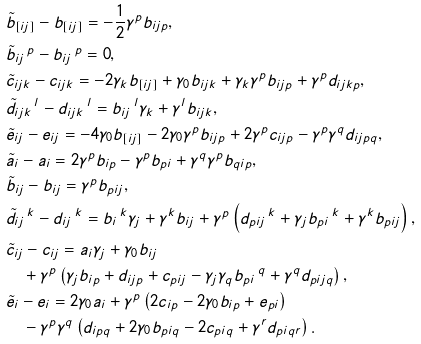Convert formula to latex. <formula><loc_0><loc_0><loc_500><loc_500>& \tilde { b } _ { [ i j ] } - b _ { [ i j ] } = - \frac { 1 } { 2 } \gamma ^ { p } b _ { i j p } , \\ & \tilde { b } _ { i j } \, ^ { p } - b _ { i j } \, ^ { p } = 0 , \\ & \tilde { c } _ { i j k } - c _ { i j k } = - 2 \gamma _ { k } b _ { [ i j ] } + \gamma _ { 0 } b _ { i j k } + \gamma _ { k } \gamma ^ { p } b _ { i j p } + \gamma ^ { p } d _ { i j k p } , \\ & \tilde { d } _ { i j k } \, ^ { l } - d _ { i j k } \, ^ { l } = b _ { i j } \, ^ { l } \gamma _ { k } + \gamma ^ { l } b _ { i j k } , \\ & \tilde { e } _ { i j } - e _ { i j } = - 4 \gamma _ { 0 } b _ { [ i j ] } - 2 \gamma _ { 0 } \gamma ^ { p } b _ { i j p } + 2 \gamma ^ { p } c _ { i j p } - \gamma ^ { p } \gamma ^ { q } d _ { i j p q } , \\ & \tilde { a } _ { i } - a _ { i } = 2 \gamma ^ { p } b _ { i p } - \gamma ^ { p } b _ { p i } + \gamma ^ { q } \gamma ^ { p } b _ { q i p } , \\ & \tilde { b } _ { i j } - b _ { i j } = \gamma ^ { p } b _ { p i j } , \\ & \tilde { d } _ { i j } \, ^ { k } - d _ { i j } \, ^ { k } = b _ { i } \, ^ { k } \gamma _ { j } + \gamma ^ { k } b _ { i j } + \gamma ^ { p } \left ( d _ { p i j } \, ^ { k } + \gamma _ { j } b _ { p i } \, ^ { k } + \gamma ^ { k } b _ { p i j } \right ) , \\ & \tilde { c } _ { i j } - c _ { i j } = a _ { i } \gamma _ { j } + \gamma _ { 0 } b _ { i j } \\ & \quad + \gamma ^ { p } \left ( \gamma _ { j } b _ { i p } + d _ { i j p } + c _ { p i j } - \gamma _ { j } \gamma _ { q } b _ { p i } \, ^ { q } + \gamma ^ { q } d _ { p i j q } \right ) , \\ & \tilde { e } _ { i } - e _ { i } = 2 \gamma _ { 0 } a _ { i } + \gamma ^ { p } \left ( 2 c _ { i p } - 2 \gamma _ { 0 } b _ { i p } + e _ { p i } \right ) \\ & \quad - \gamma ^ { p } \gamma ^ { q } \left ( d _ { i p q } + 2 \gamma _ { 0 } b _ { p i q } - 2 c _ { p i q } + \gamma ^ { r } d _ { p i q r } \right ) .</formula> 